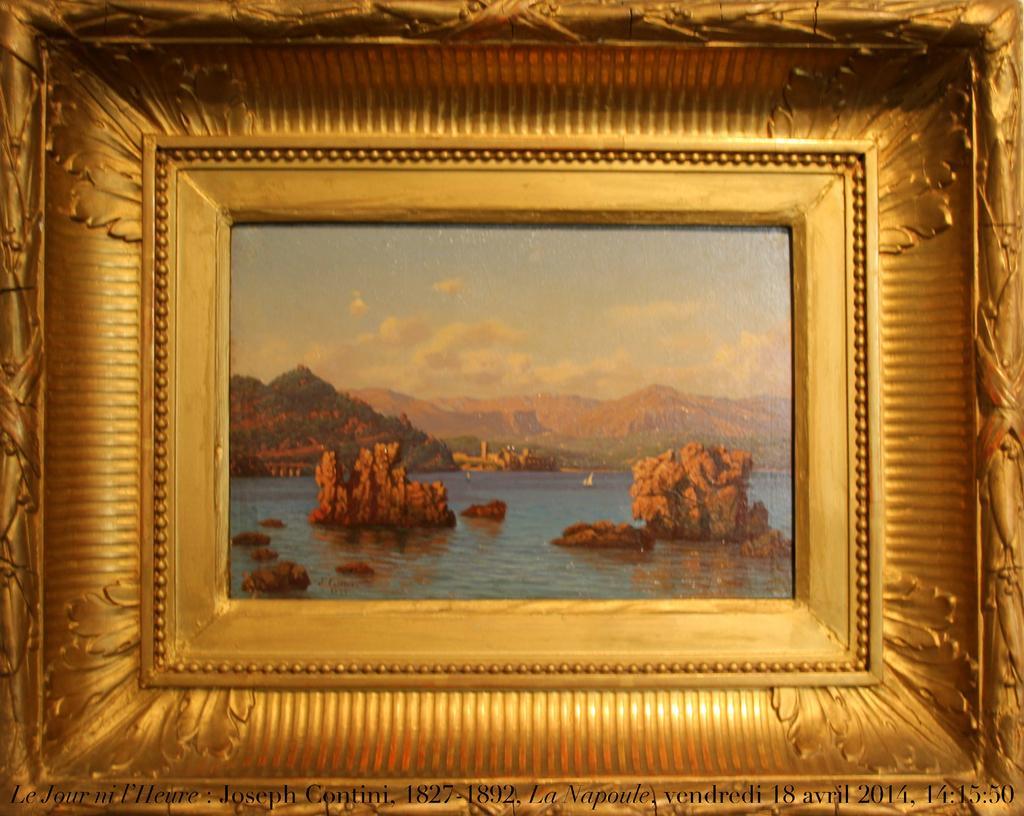Please provide a concise description of this image. In this image we can see there is a photo frame. In the photo frame there is a river, mountains and sky. 